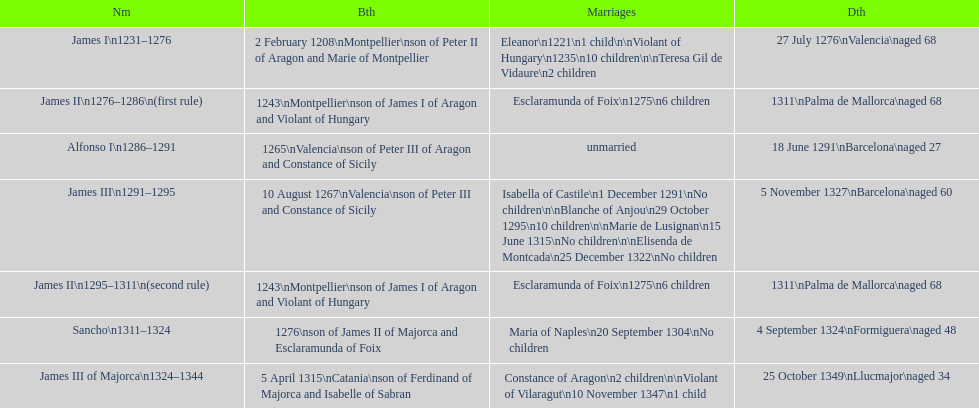Which two monarchs had no children? Alfonso I, Sancho. 